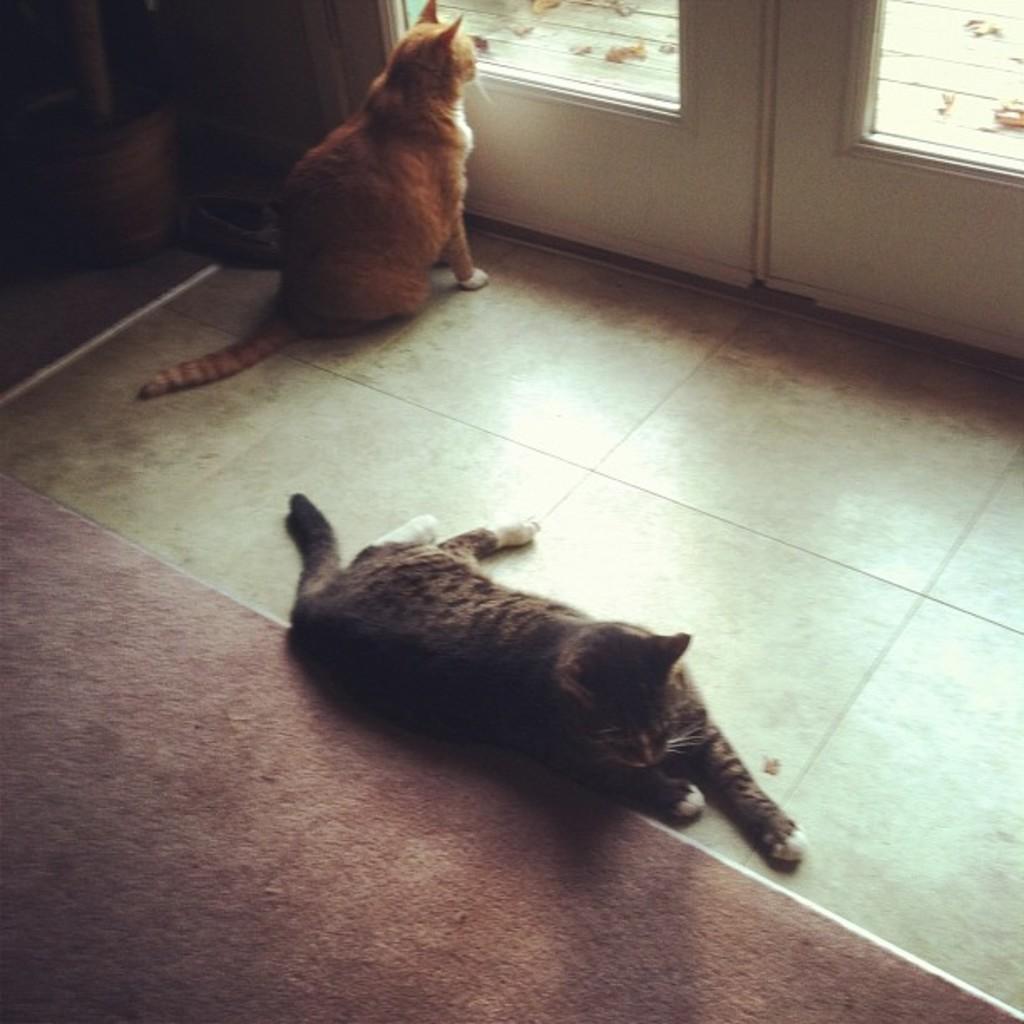Can you describe this image briefly? In this image I can see two cats. They are in black,white and brown color. I can see a white color door and floor mat. 